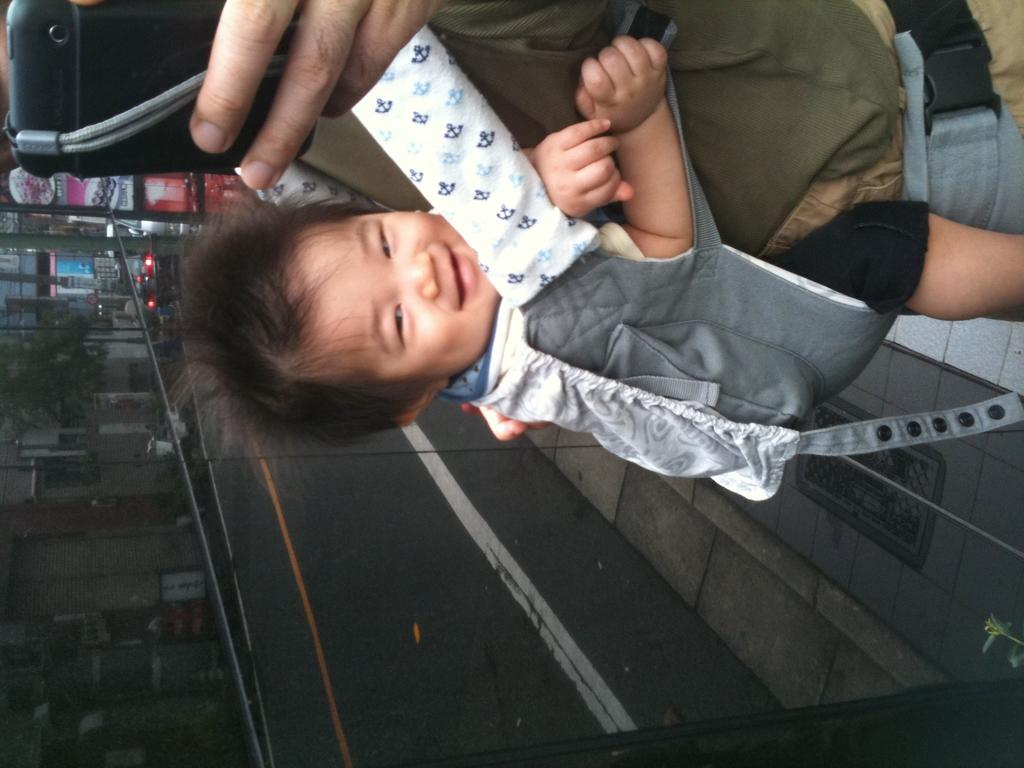What is the person in the image holding? The person is holding a mobile in the image. What else is the person carrying? The person is carrying a baby. What can be seen in the distance in the image? There are vehicles, a tree, and buildings in the background of the image. What type of muscle is being used by the person to hold the mobile? There is no mention of muscles in the image, and the person's actions do not require specific muscles to be identified. 